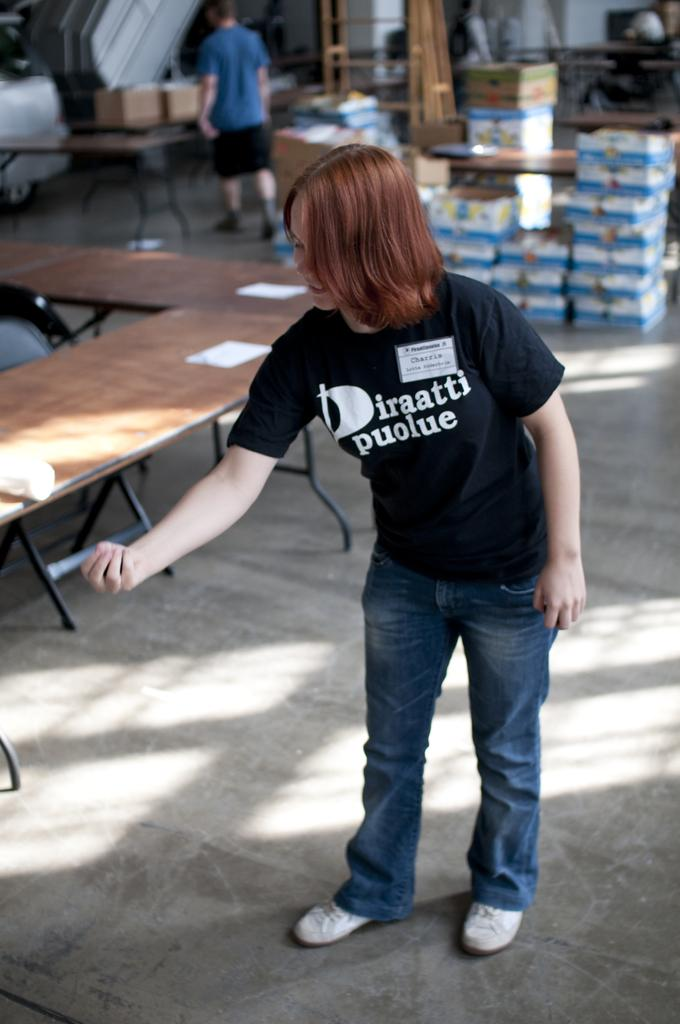What type of furniture is present in the image? There are tables in the image. Can you describe the people in the image? There are two people standing in the image. What objects are on the tables? There are boxes on the tables. What type of yoke is being used by the people in the image? There is no yoke present in the image. What scientific experiment is being conducted by the people in the image? There is no scientific experiment depicted in the image. 